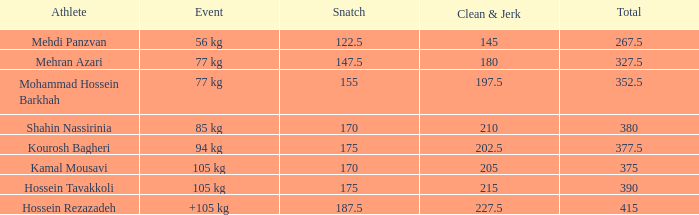What is the lowest total that had less than 170 snatches, 56 kg events and less than 145 clean & jerk? None. 